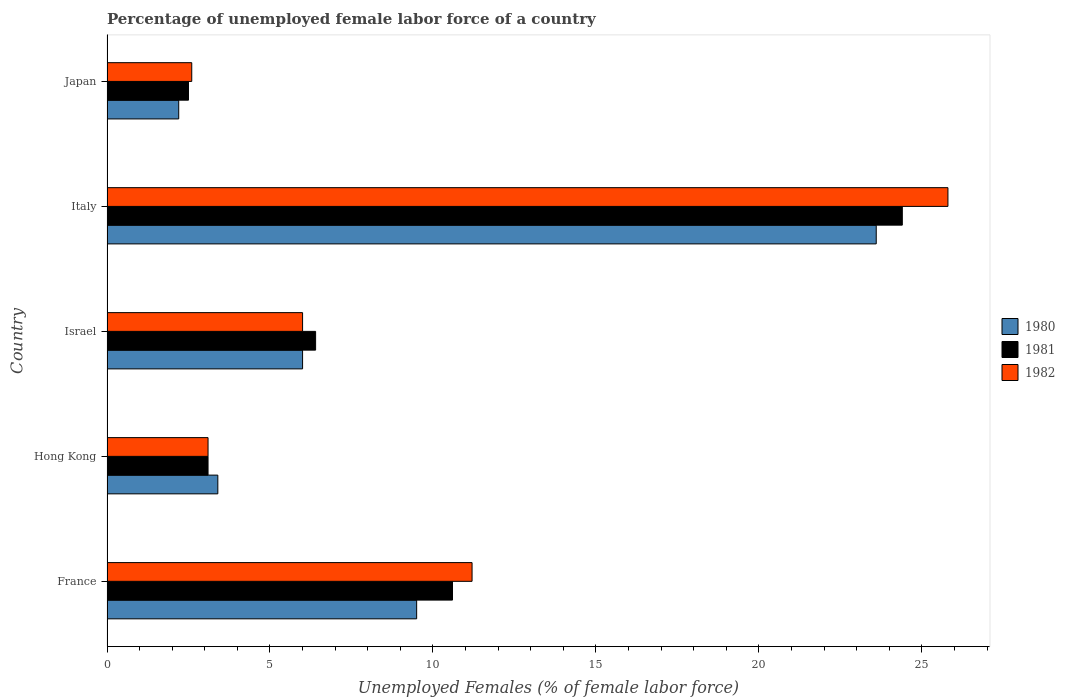How many different coloured bars are there?
Provide a short and direct response. 3. How many groups of bars are there?
Offer a very short reply. 5. Are the number of bars per tick equal to the number of legend labels?
Your answer should be very brief. Yes. How many bars are there on the 2nd tick from the top?
Make the answer very short. 3. How many bars are there on the 2nd tick from the bottom?
Keep it short and to the point. 3. What is the label of the 4th group of bars from the top?
Keep it short and to the point. Hong Kong. In how many cases, is the number of bars for a given country not equal to the number of legend labels?
Give a very brief answer. 0. What is the percentage of unemployed female labor force in 1982 in Italy?
Keep it short and to the point. 25.8. Across all countries, what is the maximum percentage of unemployed female labor force in 1980?
Keep it short and to the point. 23.6. Across all countries, what is the minimum percentage of unemployed female labor force in 1980?
Keep it short and to the point. 2.2. In which country was the percentage of unemployed female labor force in 1981 maximum?
Your answer should be very brief. Italy. What is the total percentage of unemployed female labor force in 1980 in the graph?
Your answer should be very brief. 44.7. What is the difference between the percentage of unemployed female labor force in 1981 in France and that in Italy?
Your response must be concise. -13.8. What is the difference between the percentage of unemployed female labor force in 1982 in Hong Kong and the percentage of unemployed female labor force in 1981 in France?
Provide a succinct answer. -7.5. What is the average percentage of unemployed female labor force in 1980 per country?
Your answer should be compact. 8.94. What is the difference between the percentage of unemployed female labor force in 1980 and percentage of unemployed female labor force in 1982 in Israel?
Keep it short and to the point. 0. What is the ratio of the percentage of unemployed female labor force in 1982 in Italy to that in Japan?
Ensure brevity in your answer.  9.92. What is the difference between the highest and the second highest percentage of unemployed female labor force in 1980?
Your answer should be very brief. 14.1. What is the difference between the highest and the lowest percentage of unemployed female labor force in 1982?
Offer a very short reply. 23.2. In how many countries, is the percentage of unemployed female labor force in 1981 greater than the average percentage of unemployed female labor force in 1981 taken over all countries?
Your response must be concise. 2. Is the sum of the percentage of unemployed female labor force in 1982 in France and Hong Kong greater than the maximum percentage of unemployed female labor force in 1981 across all countries?
Give a very brief answer. No. What does the 1st bar from the top in Israel represents?
Give a very brief answer. 1982. What does the 2nd bar from the bottom in France represents?
Provide a succinct answer. 1981. Is it the case that in every country, the sum of the percentage of unemployed female labor force in 1982 and percentage of unemployed female labor force in 1981 is greater than the percentage of unemployed female labor force in 1980?
Your answer should be compact. Yes. What is the difference between two consecutive major ticks on the X-axis?
Your answer should be compact. 5. Are the values on the major ticks of X-axis written in scientific E-notation?
Provide a succinct answer. No. Where does the legend appear in the graph?
Give a very brief answer. Center right. What is the title of the graph?
Give a very brief answer. Percentage of unemployed female labor force of a country. What is the label or title of the X-axis?
Offer a terse response. Unemployed Females (% of female labor force). What is the Unemployed Females (% of female labor force) in 1981 in France?
Give a very brief answer. 10.6. What is the Unemployed Females (% of female labor force) of 1982 in France?
Your answer should be very brief. 11.2. What is the Unemployed Females (% of female labor force) in 1980 in Hong Kong?
Ensure brevity in your answer.  3.4. What is the Unemployed Females (% of female labor force) of 1981 in Hong Kong?
Offer a terse response. 3.1. What is the Unemployed Females (% of female labor force) in 1982 in Hong Kong?
Ensure brevity in your answer.  3.1. What is the Unemployed Females (% of female labor force) of 1980 in Israel?
Your answer should be compact. 6. What is the Unemployed Females (% of female labor force) in 1981 in Israel?
Give a very brief answer. 6.4. What is the Unemployed Females (% of female labor force) in 1982 in Israel?
Make the answer very short. 6. What is the Unemployed Females (% of female labor force) in 1980 in Italy?
Give a very brief answer. 23.6. What is the Unemployed Females (% of female labor force) in 1981 in Italy?
Offer a very short reply. 24.4. What is the Unemployed Females (% of female labor force) in 1982 in Italy?
Ensure brevity in your answer.  25.8. What is the Unemployed Females (% of female labor force) of 1980 in Japan?
Give a very brief answer. 2.2. What is the Unemployed Females (% of female labor force) in 1982 in Japan?
Your answer should be very brief. 2.6. Across all countries, what is the maximum Unemployed Females (% of female labor force) of 1980?
Offer a very short reply. 23.6. Across all countries, what is the maximum Unemployed Females (% of female labor force) in 1981?
Make the answer very short. 24.4. Across all countries, what is the maximum Unemployed Females (% of female labor force) of 1982?
Offer a very short reply. 25.8. Across all countries, what is the minimum Unemployed Females (% of female labor force) in 1980?
Provide a short and direct response. 2.2. Across all countries, what is the minimum Unemployed Females (% of female labor force) of 1982?
Offer a very short reply. 2.6. What is the total Unemployed Females (% of female labor force) of 1980 in the graph?
Ensure brevity in your answer.  44.7. What is the total Unemployed Females (% of female labor force) of 1982 in the graph?
Ensure brevity in your answer.  48.7. What is the difference between the Unemployed Females (% of female labor force) in 1981 in France and that in Hong Kong?
Your answer should be compact. 7.5. What is the difference between the Unemployed Females (% of female labor force) of 1981 in France and that in Israel?
Make the answer very short. 4.2. What is the difference between the Unemployed Females (% of female labor force) of 1980 in France and that in Italy?
Provide a succinct answer. -14.1. What is the difference between the Unemployed Females (% of female labor force) of 1982 in France and that in Italy?
Your answer should be compact. -14.6. What is the difference between the Unemployed Females (% of female labor force) in 1981 in Hong Kong and that in Israel?
Make the answer very short. -3.3. What is the difference between the Unemployed Females (% of female labor force) of 1982 in Hong Kong and that in Israel?
Provide a succinct answer. -2.9. What is the difference between the Unemployed Females (% of female labor force) of 1980 in Hong Kong and that in Italy?
Your response must be concise. -20.2. What is the difference between the Unemployed Females (% of female labor force) in 1981 in Hong Kong and that in Italy?
Keep it short and to the point. -21.3. What is the difference between the Unemployed Females (% of female labor force) in 1982 in Hong Kong and that in Italy?
Your answer should be compact. -22.7. What is the difference between the Unemployed Females (% of female labor force) of 1980 in Hong Kong and that in Japan?
Your response must be concise. 1.2. What is the difference between the Unemployed Females (% of female labor force) in 1982 in Hong Kong and that in Japan?
Your response must be concise. 0.5. What is the difference between the Unemployed Females (% of female labor force) of 1980 in Israel and that in Italy?
Offer a very short reply. -17.6. What is the difference between the Unemployed Females (% of female labor force) of 1981 in Israel and that in Italy?
Your answer should be very brief. -18. What is the difference between the Unemployed Females (% of female labor force) in 1982 in Israel and that in Italy?
Provide a short and direct response. -19.8. What is the difference between the Unemployed Females (% of female labor force) in 1982 in Israel and that in Japan?
Your answer should be compact. 3.4. What is the difference between the Unemployed Females (% of female labor force) in 1980 in Italy and that in Japan?
Offer a very short reply. 21.4. What is the difference between the Unemployed Females (% of female labor force) in 1981 in Italy and that in Japan?
Keep it short and to the point. 21.9. What is the difference between the Unemployed Females (% of female labor force) in 1982 in Italy and that in Japan?
Provide a short and direct response. 23.2. What is the difference between the Unemployed Females (% of female labor force) of 1980 in France and the Unemployed Females (% of female labor force) of 1981 in Israel?
Offer a terse response. 3.1. What is the difference between the Unemployed Females (% of female labor force) of 1980 in France and the Unemployed Females (% of female labor force) of 1982 in Israel?
Offer a terse response. 3.5. What is the difference between the Unemployed Females (% of female labor force) of 1981 in France and the Unemployed Females (% of female labor force) of 1982 in Israel?
Keep it short and to the point. 4.6. What is the difference between the Unemployed Females (% of female labor force) of 1980 in France and the Unemployed Females (% of female labor force) of 1981 in Italy?
Offer a terse response. -14.9. What is the difference between the Unemployed Females (% of female labor force) in 1980 in France and the Unemployed Females (% of female labor force) in 1982 in Italy?
Offer a terse response. -16.3. What is the difference between the Unemployed Females (% of female labor force) in 1981 in France and the Unemployed Females (% of female labor force) in 1982 in Italy?
Offer a very short reply. -15.2. What is the difference between the Unemployed Females (% of female labor force) in 1980 in France and the Unemployed Females (% of female labor force) in 1982 in Japan?
Your answer should be very brief. 6.9. What is the difference between the Unemployed Females (% of female labor force) in 1981 in France and the Unemployed Females (% of female labor force) in 1982 in Japan?
Give a very brief answer. 8. What is the difference between the Unemployed Females (% of female labor force) of 1980 in Hong Kong and the Unemployed Females (% of female labor force) of 1981 in Israel?
Provide a short and direct response. -3. What is the difference between the Unemployed Females (% of female labor force) in 1980 in Hong Kong and the Unemployed Females (% of female labor force) in 1981 in Italy?
Provide a short and direct response. -21. What is the difference between the Unemployed Females (% of female labor force) of 1980 in Hong Kong and the Unemployed Females (% of female labor force) of 1982 in Italy?
Give a very brief answer. -22.4. What is the difference between the Unemployed Females (% of female labor force) of 1981 in Hong Kong and the Unemployed Females (% of female labor force) of 1982 in Italy?
Offer a terse response. -22.7. What is the difference between the Unemployed Females (% of female labor force) of 1980 in Hong Kong and the Unemployed Females (% of female labor force) of 1982 in Japan?
Your answer should be very brief. 0.8. What is the difference between the Unemployed Females (% of female labor force) of 1980 in Israel and the Unemployed Females (% of female labor force) of 1981 in Italy?
Your answer should be very brief. -18.4. What is the difference between the Unemployed Females (% of female labor force) of 1980 in Israel and the Unemployed Females (% of female labor force) of 1982 in Italy?
Offer a terse response. -19.8. What is the difference between the Unemployed Females (% of female labor force) in 1981 in Israel and the Unemployed Females (% of female labor force) in 1982 in Italy?
Your answer should be compact. -19.4. What is the difference between the Unemployed Females (% of female labor force) of 1980 in Israel and the Unemployed Females (% of female labor force) of 1982 in Japan?
Your answer should be very brief. 3.4. What is the difference between the Unemployed Females (% of female labor force) of 1981 in Israel and the Unemployed Females (% of female labor force) of 1982 in Japan?
Your answer should be compact. 3.8. What is the difference between the Unemployed Females (% of female labor force) in 1980 in Italy and the Unemployed Females (% of female labor force) in 1981 in Japan?
Keep it short and to the point. 21.1. What is the difference between the Unemployed Females (% of female labor force) of 1980 in Italy and the Unemployed Females (% of female labor force) of 1982 in Japan?
Keep it short and to the point. 21. What is the difference between the Unemployed Females (% of female labor force) of 1981 in Italy and the Unemployed Females (% of female labor force) of 1982 in Japan?
Offer a very short reply. 21.8. What is the average Unemployed Females (% of female labor force) of 1980 per country?
Give a very brief answer. 8.94. What is the average Unemployed Females (% of female labor force) of 1982 per country?
Provide a short and direct response. 9.74. What is the difference between the Unemployed Females (% of female labor force) in 1980 and Unemployed Females (% of female labor force) in 1981 in France?
Your response must be concise. -1.1. What is the difference between the Unemployed Females (% of female labor force) in 1980 and Unemployed Females (% of female labor force) in 1981 in Hong Kong?
Your answer should be very brief. 0.3. What is the difference between the Unemployed Females (% of female labor force) in 1981 and Unemployed Females (% of female labor force) in 1982 in Israel?
Your answer should be very brief. 0.4. What is the difference between the Unemployed Females (% of female labor force) of 1980 and Unemployed Females (% of female labor force) of 1981 in Italy?
Provide a short and direct response. -0.8. What is the difference between the Unemployed Females (% of female labor force) in 1980 and Unemployed Females (% of female labor force) in 1982 in Japan?
Your answer should be very brief. -0.4. What is the ratio of the Unemployed Females (% of female labor force) of 1980 in France to that in Hong Kong?
Provide a short and direct response. 2.79. What is the ratio of the Unemployed Females (% of female labor force) in 1981 in France to that in Hong Kong?
Make the answer very short. 3.42. What is the ratio of the Unemployed Females (% of female labor force) of 1982 in France to that in Hong Kong?
Your answer should be compact. 3.61. What is the ratio of the Unemployed Females (% of female labor force) of 1980 in France to that in Israel?
Your answer should be compact. 1.58. What is the ratio of the Unemployed Females (% of female labor force) of 1981 in France to that in Israel?
Your answer should be compact. 1.66. What is the ratio of the Unemployed Females (% of female labor force) in 1982 in France to that in Israel?
Ensure brevity in your answer.  1.87. What is the ratio of the Unemployed Females (% of female labor force) of 1980 in France to that in Italy?
Offer a very short reply. 0.4. What is the ratio of the Unemployed Females (% of female labor force) in 1981 in France to that in Italy?
Provide a succinct answer. 0.43. What is the ratio of the Unemployed Females (% of female labor force) in 1982 in France to that in Italy?
Keep it short and to the point. 0.43. What is the ratio of the Unemployed Females (% of female labor force) of 1980 in France to that in Japan?
Your response must be concise. 4.32. What is the ratio of the Unemployed Females (% of female labor force) of 1981 in France to that in Japan?
Make the answer very short. 4.24. What is the ratio of the Unemployed Females (% of female labor force) in 1982 in France to that in Japan?
Make the answer very short. 4.31. What is the ratio of the Unemployed Females (% of female labor force) of 1980 in Hong Kong to that in Israel?
Provide a short and direct response. 0.57. What is the ratio of the Unemployed Females (% of female labor force) in 1981 in Hong Kong to that in Israel?
Provide a succinct answer. 0.48. What is the ratio of the Unemployed Females (% of female labor force) of 1982 in Hong Kong to that in Israel?
Offer a very short reply. 0.52. What is the ratio of the Unemployed Females (% of female labor force) of 1980 in Hong Kong to that in Italy?
Make the answer very short. 0.14. What is the ratio of the Unemployed Females (% of female labor force) of 1981 in Hong Kong to that in Italy?
Provide a succinct answer. 0.13. What is the ratio of the Unemployed Females (% of female labor force) in 1982 in Hong Kong to that in Italy?
Give a very brief answer. 0.12. What is the ratio of the Unemployed Females (% of female labor force) in 1980 in Hong Kong to that in Japan?
Provide a short and direct response. 1.55. What is the ratio of the Unemployed Females (% of female labor force) of 1981 in Hong Kong to that in Japan?
Provide a short and direct response. 1.24. What is the ratio of the Unemployed Females (% of female labor force) of 1982 in Hong Kong to that in Japan?
Keep it short and to the point. 1.19. What is the ratio of the Unemployed Females (% of female labor force) of 1980 in Israel to that in Italy?
Offer a very short reply. 0.25. What is the ratio of the Unemployed Females (% of female labor force) in 1981 in Israel to that in Italy?
Ensure brevity in your answer.  0.26. What is the ratio of the Unemployed Females (% of female labor force) in 1982 in Israel to that in Italy?
Give a very brief answer. 0.23. What is the ratio of the Unemployed Females (% of female labor force) of 1980 in Israel to that in Japan?
Give a very brief answer. 2.73. What is the ratio of the Unemployed Females (% of female labor force) of 1981 in Israel to that in Japan?
Your answer should be very brief. 2.56. What is the ratio of the Unemployed Females (% of female labor force) of 1982 in Israel to that in Japan?
Provide a succinct answer. 2.31. What is the ratio of the Unemployed Females (% of female labor force) of 1980 in Italy to that in Japan?
Your answer should be compact. 10.73. What is the ratio of the Unemployed Females (% of female labor force) of 1981 in Italy to that in Japan?
Your answer should be very brief. 9.76. What is the ratio of the Unemployed Females (% of female labor force) in 1982 in Italy to that in Japan?
Provide a succinct answer. 9.92. What is the difference between the highest and the second highest Unemployed Females (% of female labor force) of 1980?
Make the answer very short. 14.1. What is the difference between the highest and the second highest Unemployed Females (% of female labor force) in 1982?
Give a very brief answer. 14.6. What is the difference between the highest and the lowest Unemployed Females (% of female labor force) of 1980?
Provide a short and direct response. 21.4. What is the difference between the highest and the lowest Unemployed Females (% of female labor force) of 1981?
Ensure brevity in your answer.  21.9. What is the difference between the highest and the lowest Unemployed Females (% of female labor force) of 1982?
Provide a succinct answer. 23.2. 